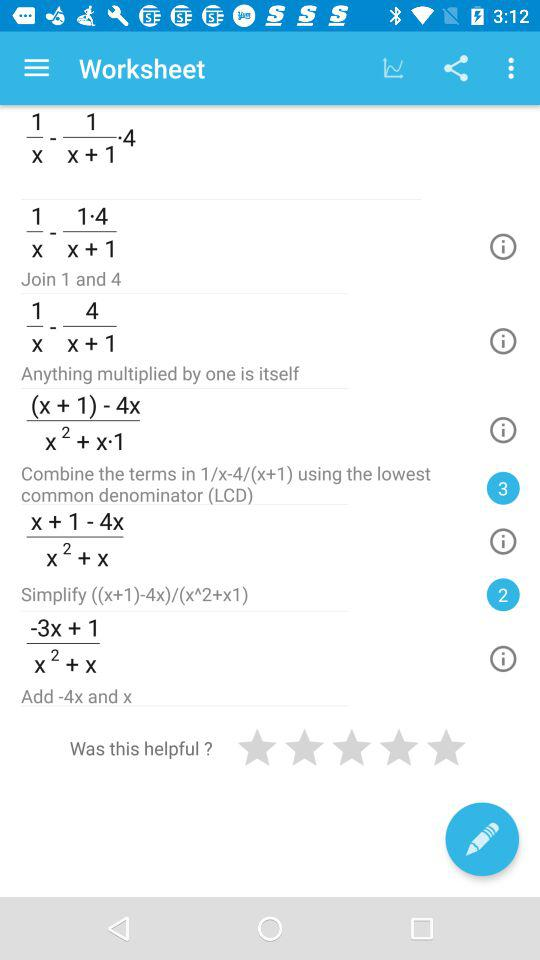What is the value of (x + 1) - 4x?
Answer the question using a single word or phrase. -3x + 1 